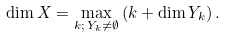Convert formula to latex. <formula><loc_0><loc_0><loc_500><loc_500>\dim X = \max _ { k ; \, Y _ { k } \neq \emptyset } \left ( k + \dim Y _ { k } \right ) .</formula> 